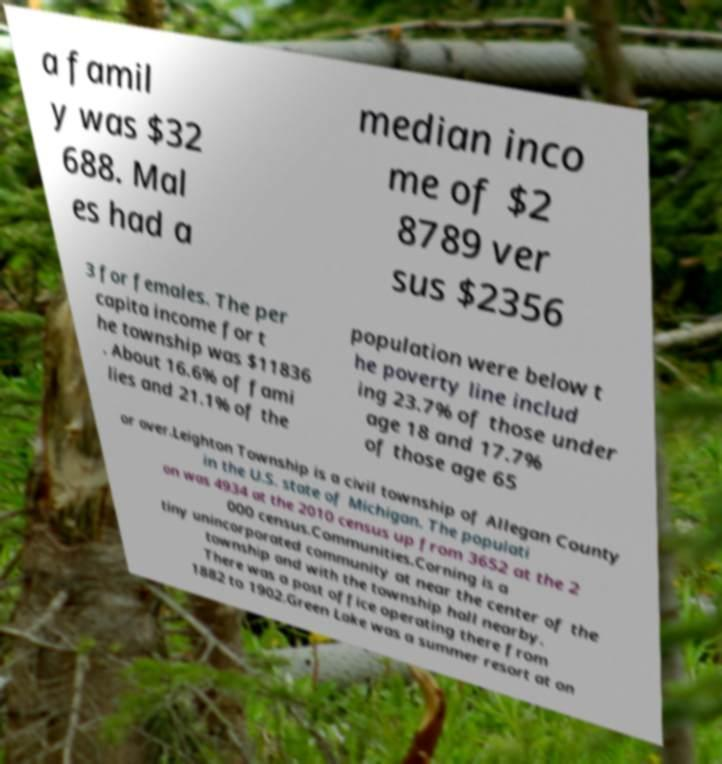What messages or text are displayed in this image? I need them in a readable, typed format. a famil y was $32 688. Mal es had a median inco me of $2 8789 ver sus $2356 3 for females. The per capita income for t he township was $11836 . About 16.6% of fami lies and 21.1% of the population were below t he poverty line includ ing 23.7% of those under age 18 and 17.7% of those age 65 or over.Leighton Township is a civil township of Allegan County in the U.S. state of Michigan. The populati on was 4934 at the 2010 census up from 3652 at the 2 000 census.Communities.Corning is a tiny unincorporated community at near the center of the township and with the township hall nearby. There was a post office operating there from 1882 to 1902.Green Lake was a summer resort at on 